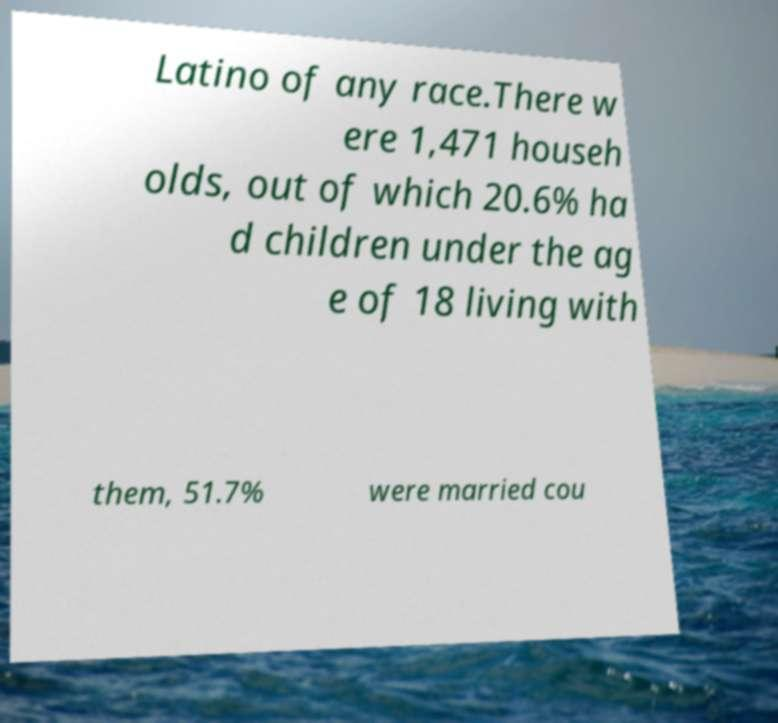Can you accurately transcribe the text from the provided image for me? Latino of any race.There w ere 1,471 househ olds, out of which 20.6% ha d children under the ag e of 18 living with them, 51.7% were married cou 